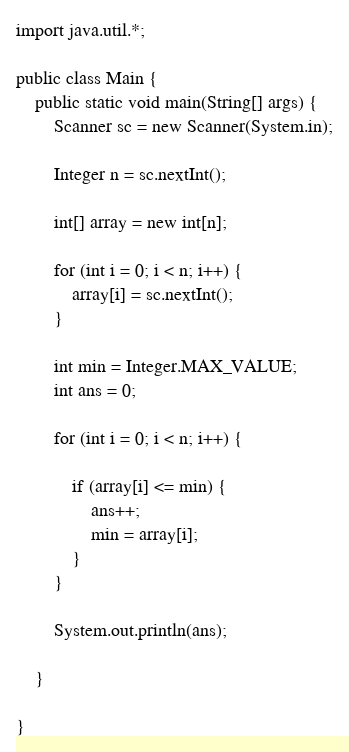Convert code to text. <code><loc_0><loc_0><loc_500><loc_500><_Java_>import java.util.*;

public class Main {
    public static void main(String[] args) {
        Scanner sc = new Scanner(System.in);

        Integer n = sc.nextInt();

        int[] array = new int[n];

        for (int i = 0; i < n; i++) {
            array[i] = sc.nextInt();
        }

        int min = Integer.MAX_VALUE;
        int ans = 0;

        for (int i = 0; i < n; i++) {

            if (array[i] <= min) {
                ans++;
                min = array[i];
            }
        }

        System.out.println(ans);

    }

}</code> 